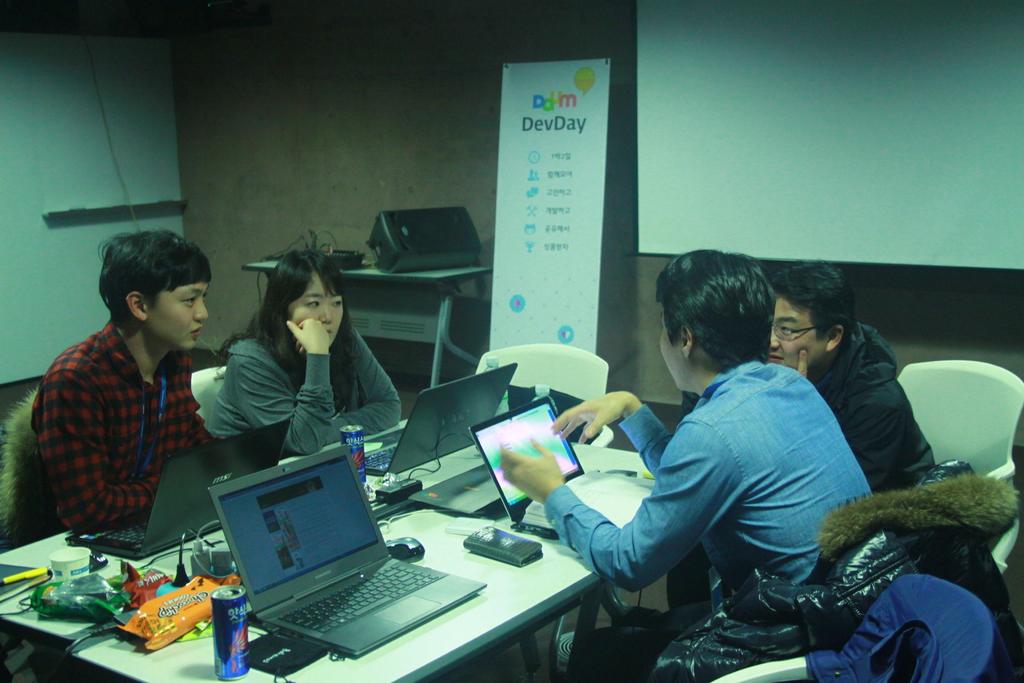What does it say at the top of the poster on the right?
Your answer should be very brief. Devday. 